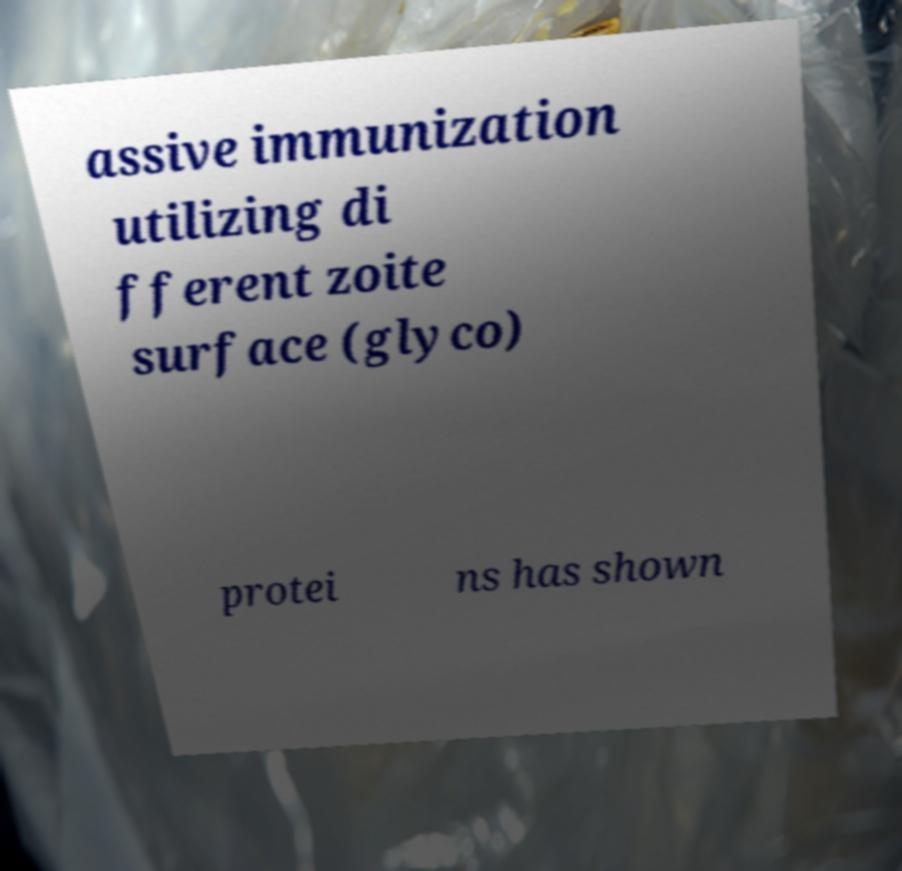I need the written content from this picture converted into text. Can you do that? assive immunization utilizing di fferent zoite surface (glyco) protei ns has shown 